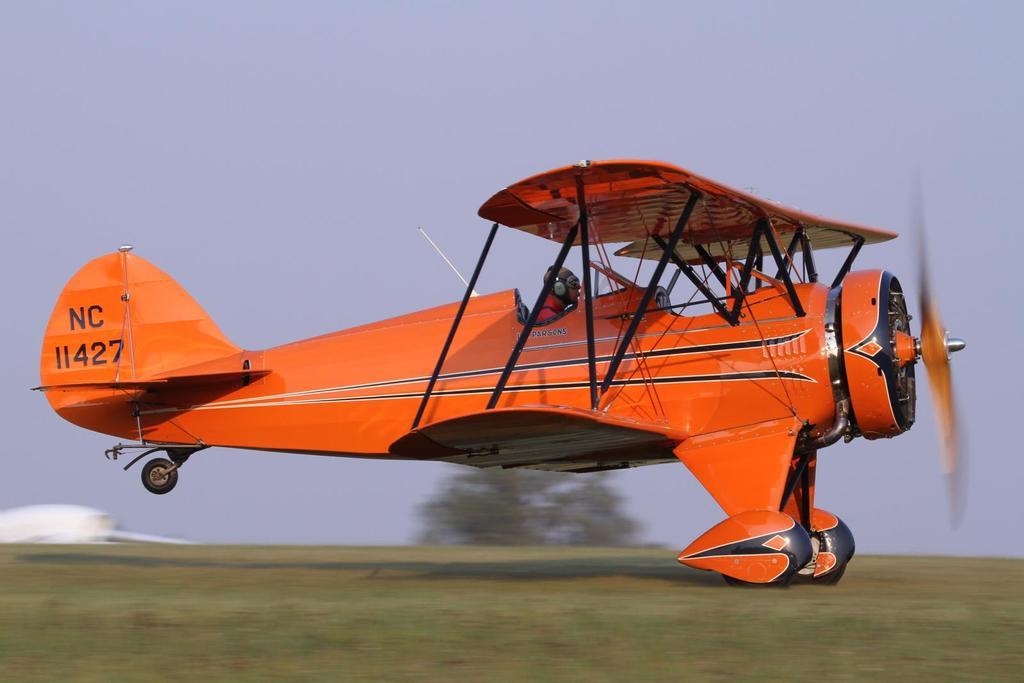What letters are on the plane's tail?
Provide a short and direct response. Nc. What is the plane number?
Your answer should be very brief. 11427. 